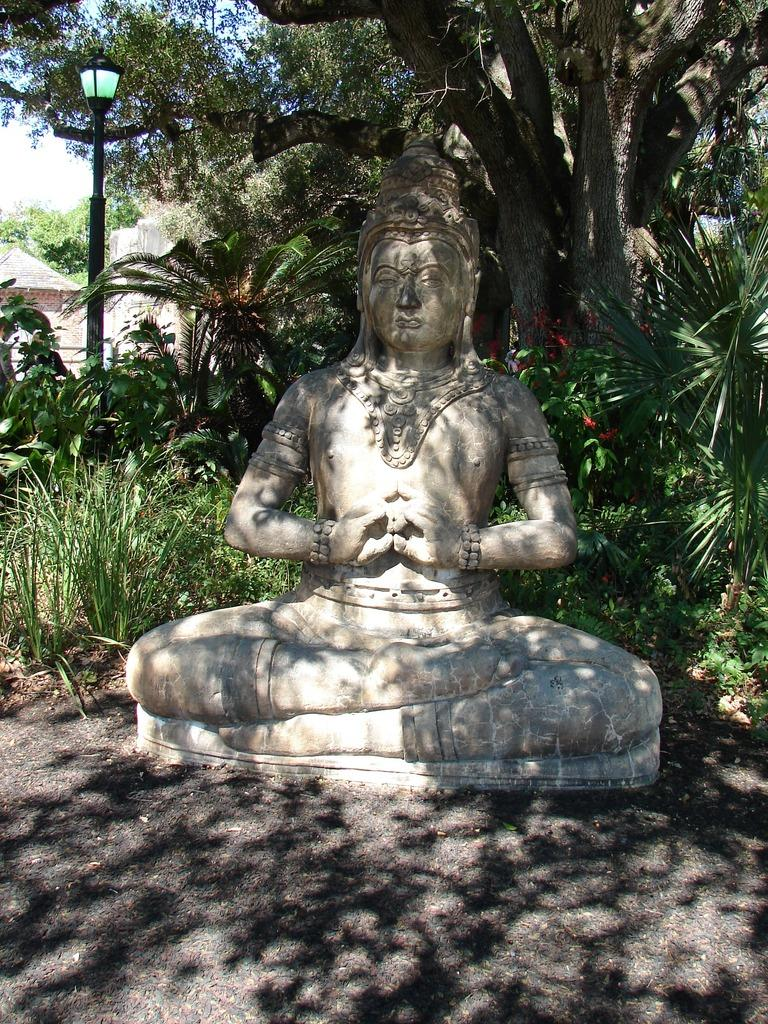What is the main subject in the center of the image? There is a sculpture in the center of the image. What can be seen in the background of the image? There are trees and a shed in the background of the image. What other object is present in the image? There is a pole in the image. What part of the natural environment is visible in the image? The sky is visible in the image. What type of blade is attached to the sculpture in the image? There is no blade attached to the sculpture in the image. What kind of apparatus is used to maintain the trees in the image? There is no apparatus visible in the image for maintaining the trees. 